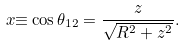Convert formula to latex. <formula><loc_0><loc_0><loc_500><loc_500>x { \equiv } \cos \theta _ { 1 2 } = \frac { z } { \sqrt { R ^ { 2 } + z ^ { 2 } } } .</formula> 